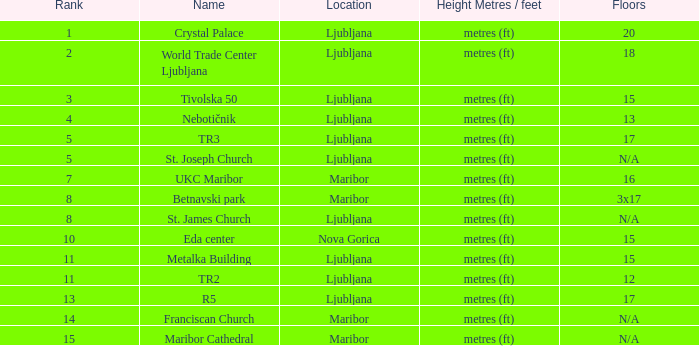Which Name has a Location of ljubljana? Crystal Palace, World Trade Center Ljubljana, Tivolska 50, Nebotičnik, TR3, St. Joseph Church, St. James Church, Metalka Building, TR2, R5. 